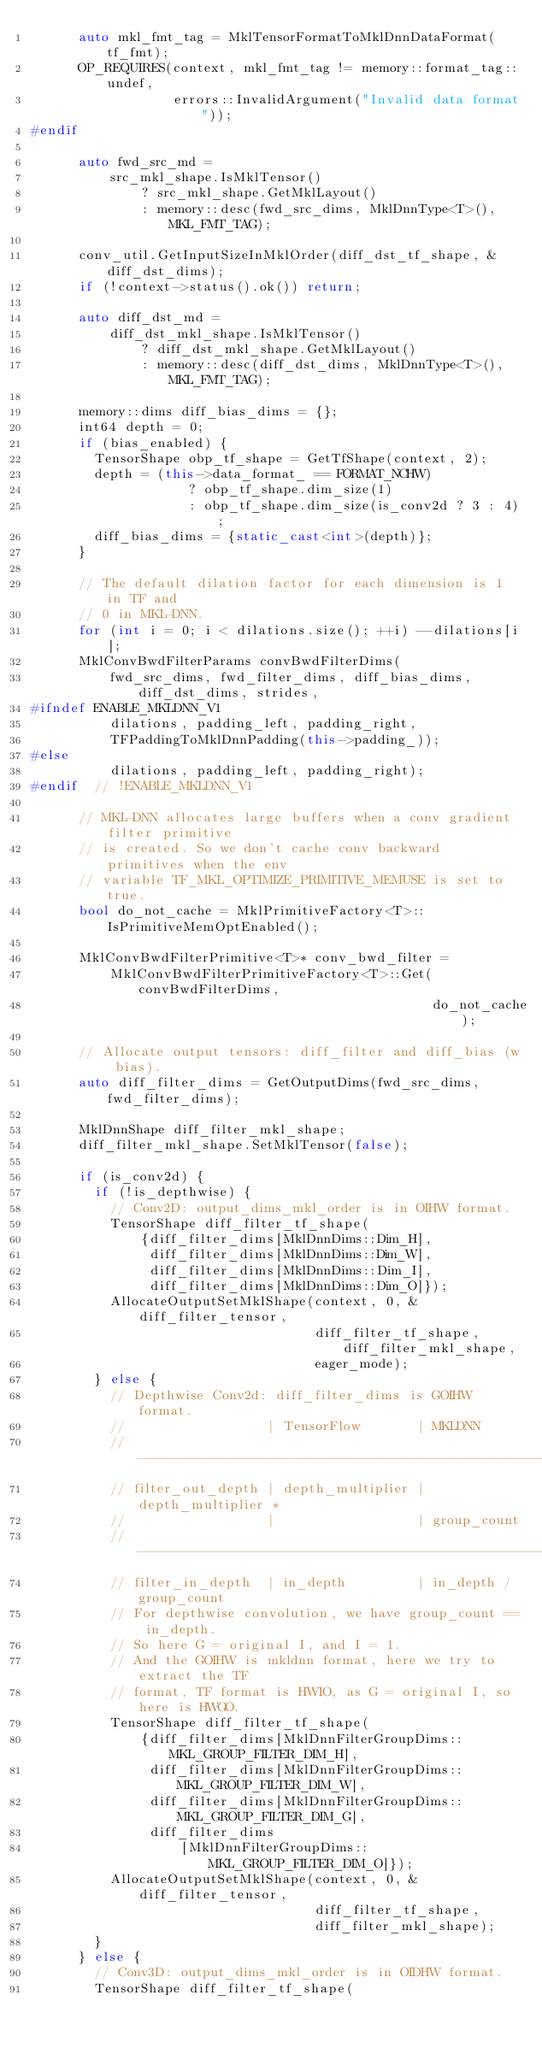<code> <loc_0><loc_0><loc_500><loc_500><_C++_>      auto mkl_fmt_tag = MklTensorFormatToMklDnnDataFormat(tf_fmt);
      OP_REQUIRES(context, mkl_fmt_tag != memory::format_tag::undef,
                  errors::InvalidArgument("Invalid data format"));
#endif

      auto fwd_src_md =
          src_mkl_shape.IsMklTensor()
              ? src_mkl_shape.GetMklLayout()
              : memory::desc(fwd_src_dims, MklDnnType<T>(), MKL_FMT_TAG);

      conv_util.GetInputSizeInMklOrder(diff_dst_tf_shape, &diff_dst_dims);
      if (!context->status().ok()) return;

      auto diff_dst_md =
          diff_dst_mkl_shape.IsMklTensor()
              ? diff_dst_mkl_shape.GetMklLayout()
              : memory::desc(diff_dst_dims, MklDnnType<T>(), MKL_FMT_TAG);

      memory::dims diff_bias_dims = {};
      int64 depth = 0;
      if (bias_enabled) {
        TensorShape obp_tf_shape = GetTfShape(context, 2);
        depth = (this->data_format_ == FORMAT_NCHW)
                    ? obp_tf_shape.dim_size(1)
                    : obp_tf_shape.dim_size(is_conv2d ? 3 : 4);
        diff_bias_dims = {static_cast<int>(depth)};
      }

      // The default dilation factor for each dimension is 1 in TF and
      // 0 in MKL-DNN.
      for (int i = 0; i < dilations.size(); ++i) --dilations[i];
      MklConvBwdFilterParams convBwdFilterDims(
          fwd_src_dims, fwd_filter_dims, diff_bias_dims, diff_dst_dims, strides,
#ifndef ENABLE_MKLDNN_V1
          dilations, padding_left, padding_right,
          TFPaddingToMklDnnPadding(this->padding_));
#else
          dilations, padding_left, padding_right);
#endif  // !ENABLE_MKLDNN_V1

      // MKL-DNN allocates large buffers when a conv gradient filter primitive
      // is created. So we don't cache conv backward primitives when the env
      // variable TF_MKL_OPTIMIZE_PRIMITIVE_MEMUSE is set to true.
      bool do_not_cache = MklPrimitiveFactory<T>::IsPrimitiveMemOptEnabled();

      MklConvBwdFilterPrimitive<T>* conv_bwd_filter =
          MklConvBwdFilterPrimitiveFactory<T>::Get(convBwdFilterDims,
                                                   do_not_cache);

      // Allocate output tensors: diff_filter and diff_bias (w bias).
      auto diff_filter_dims = GetOutputDims(fwd_src_dims, fwd_filter_dims);

      MklDnnShape diff_filter_mkl_shape;
      diff_filter_mkl_shape.SetMklTensor(false);

      if (is_conv2d) {
        if (!is_depthwise) {
          // Conv2D: output_dims_mkl_order is in OIHW format.
          TensorShape diff_filter_tf_shape(
              {diff_filter_dims[MklDnnDims::Dim_H],
               diff_filter_dims[MklDnnDims::Dim_W],
               diff_filter_dims[MklDnnDims::Dim_I],
               diff_filter_dims[MklDnnDims::Dim_O]});
          AllocateOutputSetMklShape(context, 0, &diff_filter_tensor,
                                    diff_filter_tf_shape, diff_filter_mkl_shape,
                                    eager_mode);
        } else {
          // Depthwise Conv2d: diff_filter_dims is GOIHW format.
          //                  | TensorFlow       | MKLDNN
          // ----------------------------------------------------------------
          // filter_out_depth | depth_multiplier | depth_multiplier *
          //                  |                  | group_count
          // ----------------------------------------------------------------
          // filter_in_depth  | in_depth         | in_depth / group_count
          // For depthwise convolution, we have group_count == in_depth.
          // So here G = original I, and I = 1.
          // And the GOIHW is mkldnn format, here we try to extract the TF
          // format, TF format is HWIO, as G = original I, so here is HWGO.
          TensorShape diff_filter_tf_shape(
              {diff_filter_dims[MklDnnFilterGroupDims::MKL_GROUP_FILTER_DIM_H],
               diff_filter_dims[MklDnnFilterGroupDims::MKL_GROUP_FILTER_DIM_W],
               diff_filter_dims[MklDnnFilterGroupDims::MKL_GROUP_FILTER_DIM_G],
               diff_filter_dims
                   [MklDnnFilterGroupDims::MKL_GROUP_FILTER_DIM_O]});
          AllocateOutputSetMklShape(context, 0, &diff_filter_tensor,
                                    diff_filter_tf_shape,
                                    diff_filter_mkl_shape);
        }
      } else {
        // Conv3D: output_dims_mkl_order is in OIDHW format.
        TensorShape diff_filter_tf_shape(</code> 